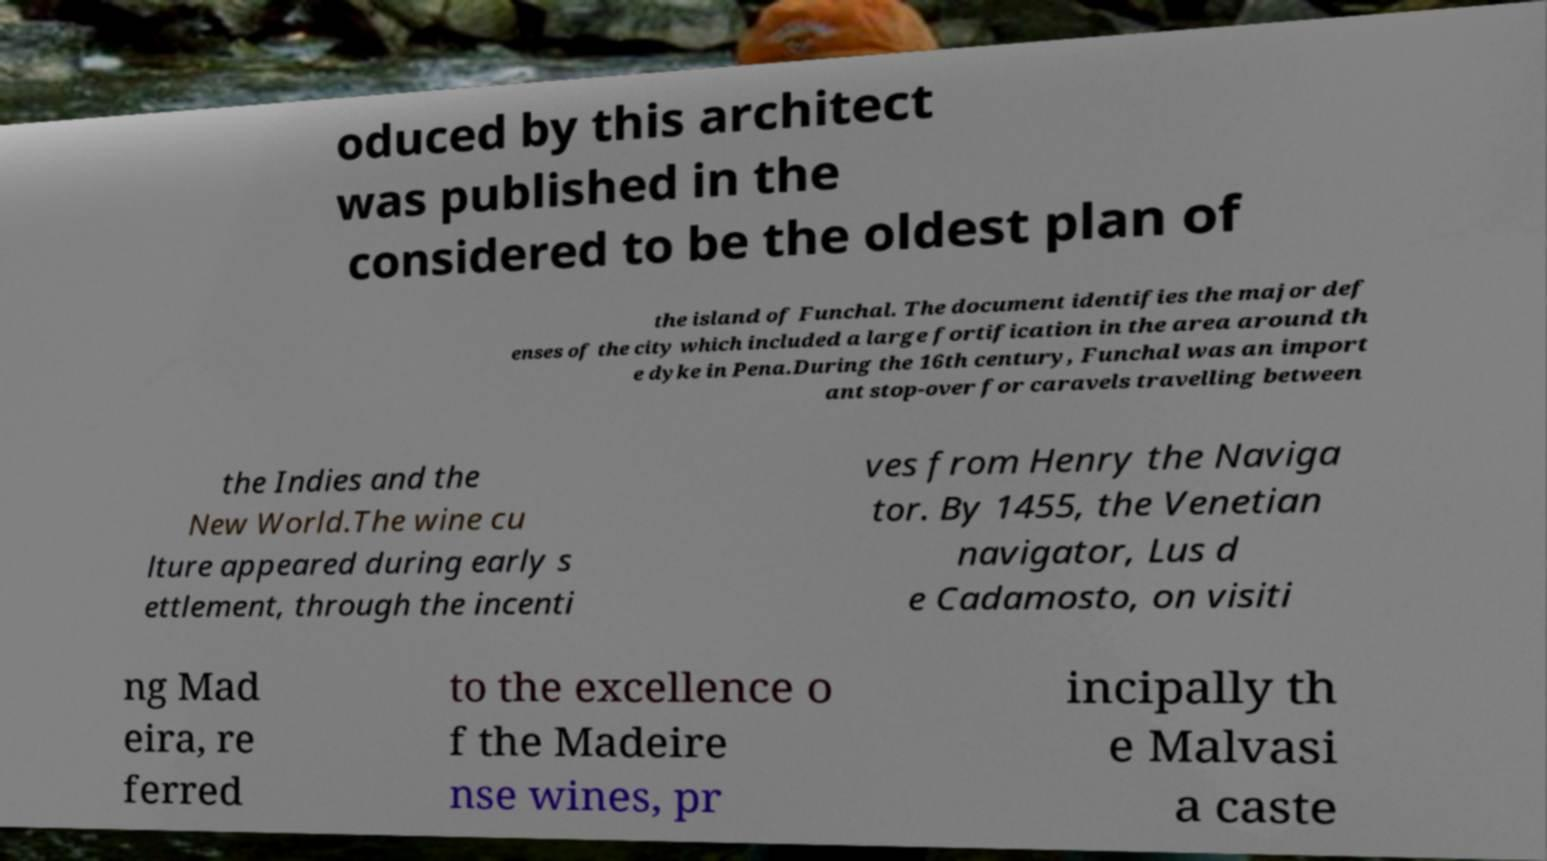Please read and relay the text visible in this image. What does it say? oduced by this architect was published in the considered to be the oldest plan of the island of Funchal. The document identifies the major def enses of the city which included a large fortification in the area around th e dyke in Pena.During the 16th century, Funchal was an import ant stop-over for caravels travelling between the Indies and the New World.The wine cu lture appeared during early s ettlement, through the incenti ves from Henry the Naviga tor. By 1455, the Venetian navigator, Lus d e Cadamosto, on visiti ng Mad eira, re ferred to the excellence o f the Madeire nse wines, pr incipally th e Malvasi a caste 